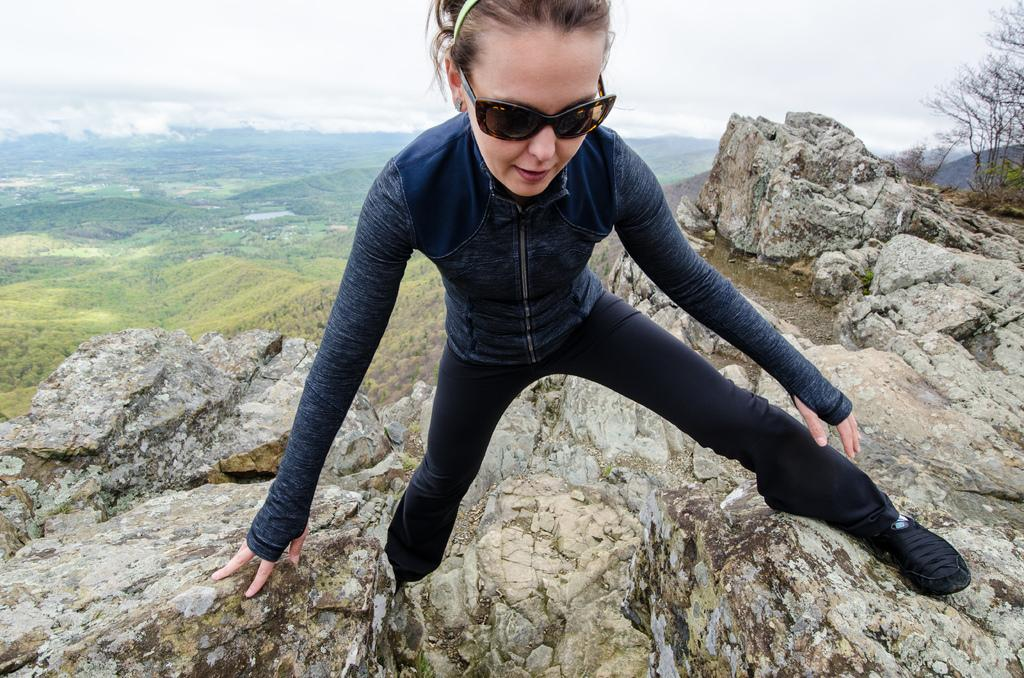What is the main subject of the image? There is a person on the rock hill in the image. What can be seen in the top right corner of the image? There are plants in the top right of the image. What is visible at the top of the image? The sky is visible at the top of the image. What type of game is being played on the rock hill in the image? There is no game being played in the image; it simply shows a person on a rock hill. How many candles are on the birthday cake in the image? There is no birthday cake present in the image. 